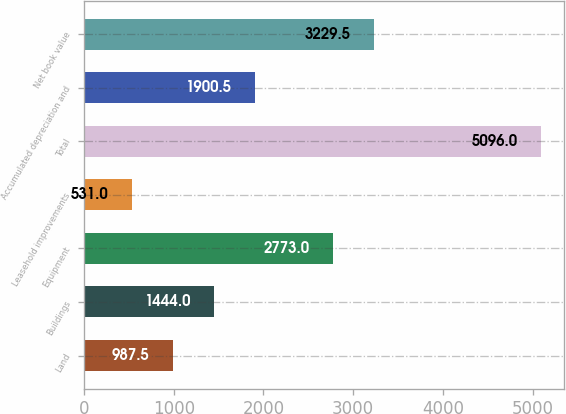<chart> <loc_0><loc_0><loc_500><loc_500><bar_chart><fcel>Land<fcel>Buildings<fcel>Equipment<fcel>Leasehold improvements<fcel>Total<fcel>Accumulated depreciation and<fcel>Net book value<nl><fcel>987.5<fcel>1444<fcel>2773<fcel>531<fcel>5096<fcel>1900.5<fcel>3229.5<nl></chart> 